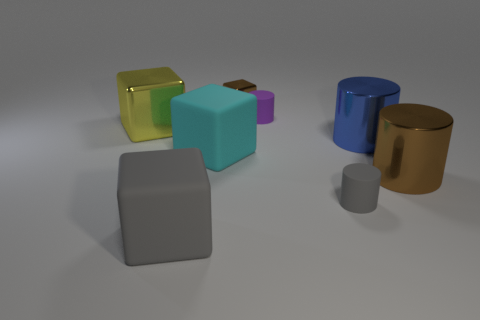Subtract all large cyan cubes. How many cubes are left? 3 Add 1 shiny cylinders. How many objects exist? 9 Subtract all yellow cubes. How many cubes are left? 3 Subtract all cyan cylinders. Subtract all blue balls. How many cylinders are left? 4 Subtract all blue cylinders. How many green blocks are left? 0 Subtract all tiny yellow objects. Subtract all large matte things. How many objects are left? 6 Add 8 big gray matte cubes. How many big gray matte cubes are left? 9 Add 8 tiny yellow matte blocks. How many tiny yellow matte blocks exist? 8 Subtract 0 gray spheres. How many objects are left? 8 Subtract 2 cubes. How many cubes are left? 2 